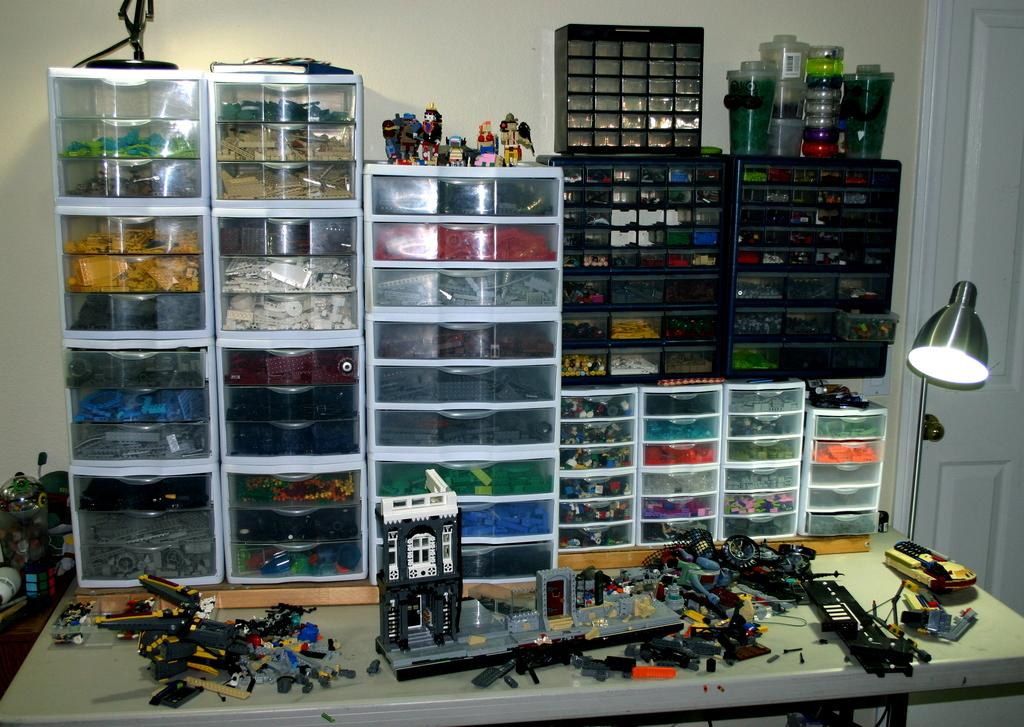What type of items can be seen on the table in the image? There are puzzle games and toys placed on a white table in the image. How are the puzzle blocks stored in the image? The puzzle blocks are stored in plastic boxes in the image. What color is the wall visible in the image? There is a white wall visible in the image. What type of government is depicted in the image? There is no depiction of a government in the image; it features puzzle games and toys on a white table. Can you see any ocean in the image? There is no ocean present in the image. 